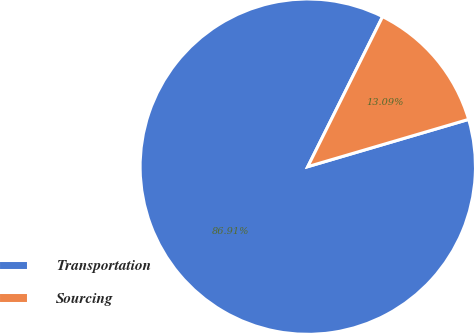Convert chart. <chart><loc_0><loc_0><loc_500><loc_500><pie_chart><fcel>Transportation<fcel>Sourcing<nl><fcel>86.91%<fcel>13.09%<nl></chart> 